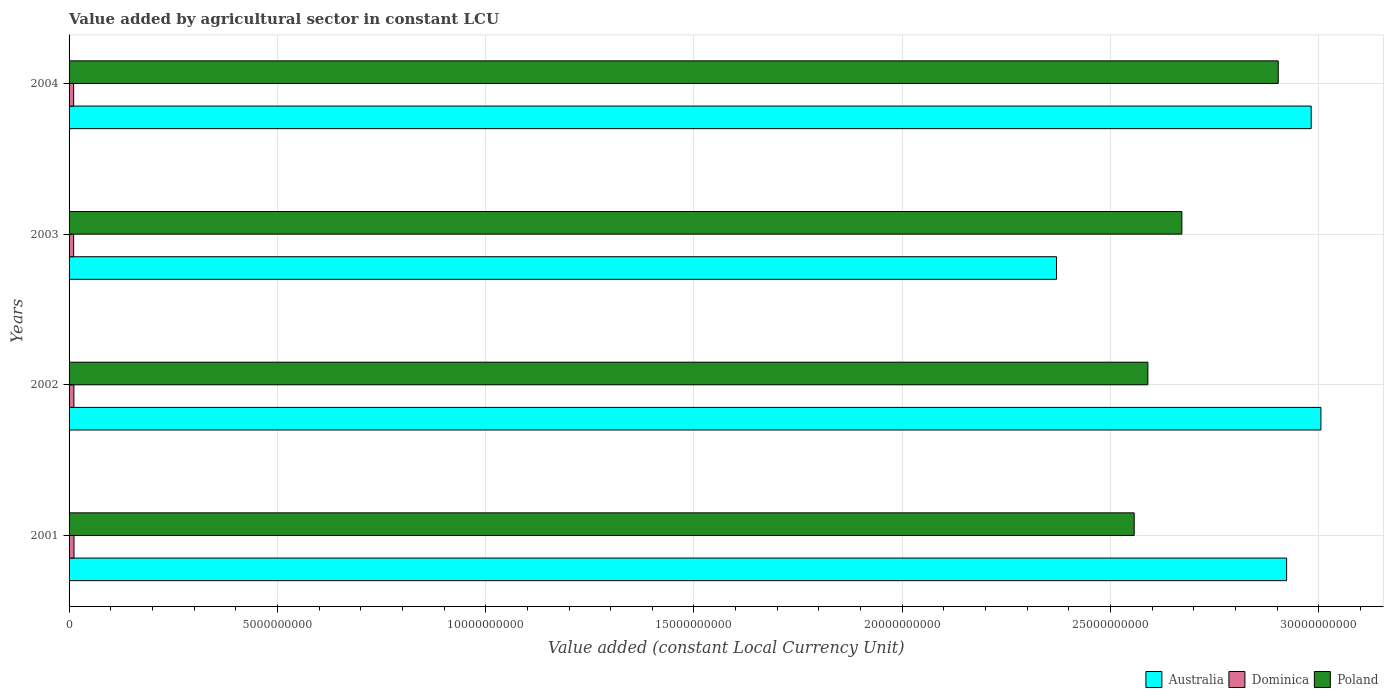How many different coloured bars are there?
Keep it short and to the point. 3. How many groups of bars are there?
Provide a succinct answer. 4. Are the number of bars per tick equal to the number of legend labels?
Provide a succinct answer. Yes. How many bars are there on the 3rd tick from the bottom?
Your response must be concise. 3. What is the label of the 3rd group of bars from the top?
Offer a very short reply. 2002. In how many cases, is the number of bars for a given year not equal to the number of legend labels?
Provide a short and direct response. 0. What is the value added by agricultural sector in Australia in 2003?
Keep it short and to the point. 2.37e+1. Across all years, what is the maximum value added by agricultural sector in Dominica?
Give a very brief answer. 1.18e+08. Across all years, what is the minimum value added by agricultural sector in Dominica?
Offer a very short reply. 1.10e+08. In which year was the value added by agricultural sector in Poland maximum?
Your answer should be compact. 2004. What is the total value added by agricultural sector in Australia in the graph?
Offer a terse response. 1.13e+11. What is the difference between the value added by agricultural sector in Poland in 2002 and that in 2004?
Make the answer very short. -3.13e+09. What is the difference between the value added by agricultural sector in Dominica in 2001 and the value added by agricultural sector in Poland in 2002?
Your response must be concise. -2.58e+1. What is the average value added by agricultural sector in Poland per year?
Keep it short and to the point. 2.68e+1. In the year 2002, what is the difference between the value added by agricultural sector in Poland and value added by agricultural sector in Australia?
Your response must be concise. -4.15e+09. What is the ratio of the value added by agricultural sector in Australia in 2003 to that in 2004?
Ensure brevity in your answer.  0.79. Is the value added by agricultural sector in Dominica in 2001 less than that in 2002?
Provide a succinct answer. No. Is the difference between the value added by agricultural sector in Poland in 2001 and 2004 greater than the difference between the value added by agricultural sector in Australia in 2001 and 2004?
Your answer should be very brief. No. What is the difference between the highest and the second highest value added by agricultural sector in Dominica?
Offer a very short reply. 2.83e+06. What is the difference between the highest and the lowest value added by agricultural sector in Australia?
Offer a terse response. 6.35e+09. Is the sum of the value added by agricultural sector in Dominica in 2002 and 2004 greater than the maximum value added by agricultural sector in Poland across all years?
Keep it short and to the point. No. What does the 2nd bar from the top in 2003 represents?
Provide a succinct answer. Dominica. What does the 3rd bar from the bottom in 2002 represents?
Give a very brief answer. Poland. Is it the case that in every year, the sum of the value added by agricultural sector in Australia and value added by agricultural sector in Dominica is greater than the value added by agricultural sector in Poland?
Make the answer very short. No. Are all the bars in the graph horizontal?
Make the answer very short. Yes. Are the values on the major ticks of X-axis written in scientific E-notation?
Provide a succinct answer. No. Does the graph contain any zero values?
Your answer should be very brief. No. What is the title of the graph?
Provide a succinct answer. Value added by agricultural sector in constant LCU. What is the label or title of the X-axis?
Offer a very short reply. Value added (constant Local Currency Unit). What is the label or title of the Y-axis?
Provide a succinct answer. Years. What is the Value added (constant Local Currency Unit) in Australia in 2001?
Keep it short and to the point. 2.92e+1. What is the Value added (constant Local Currency Unit) of Dominica in 2001?
Your answer should be compact. 1.18e+08. What is the Value added (constant Local Currency Unit) in Poland in 2001?
Provide a short and direct response. 2.56e+1. What is the Value added (constant Local Currency Unit) of Australia in 2002?
Give a very brief answer. 3.00e+1. What is the Value added (constant Local Currency Unit) in Dominica in 2002?
Your answer should be very brief. 1.16e+08. What is the Value added (constant Local Currency Unit) in Poland in 2002?
Provide a short and direct response. 2.59e+1. What is the Value added (constant Local Currency Unit) of Australia in 2003?
Provide a succinct answer. 2.37e+1. What is the Value added (constant Local Currency Unit) of Dominica in 2003?
Your answer should be compact. 1.10e+08. What is the Value added (constant Local Currency Unit) in Poland in 2003?
Offer a terse response. 2.67e+1. What is the Value added (constant Local Currency Unit) of Australia in 2004?
Ensure brevity in your answer.  2.98e+1. What is the Value added (constant Local Currency Unit) in Dominica in 2004?
Ensure brevity in your answer.  1.10e+08. What is the Value added (constant Local Currency Unit) in Poland in 2004?
Provide a succinct answer. 2.90e+1. Across all years, what is the maximum Value added (constant Local Currency Unit) in Australia?
Provide a short and direct response. 3.00e+1. Across all years, what is the maximum Value added (constant Local Currency Unit) of Dominica?
Offer a very short reply. 1.18e+08. Across all years, what is the maximum Value added (constant Local Currency Unit) in Poland?
Provide a succinct answer. 2.90e+1. Across all years, what is the minimum Value added (constant Local Currency Unit) of Australia?
Your response must be concise. 2.37e+1. Across all years, what is the minimum Value added (constant Local Currency Unit) in Dominica?
Ensure brevity in your answer.  1.10e+08. Across all years, what is the minimum Value added (constant Local Currency Unit) in Poland?
Ensure brevity in your answer.  2.56e+1. What is the total Value added (constant Local Currency Unit) in Australia in the graph?
Provide a short and direct response. 1.13e+11. What is the total Value added (constant Local Currency Unit) of Dominica in the graph?
Your answer should be very brief. 4.53e+08. What is the total Value added (constant Local Currency Unit) of Poland in the graph?
Your answer should be compact. 1.07e+11. What is the difference between the Value added (constant Local Currency Unit) in Australia in 2001 and that in 2002?
Provide a succinct answer. -8.23e+08. What is the difference between the Value added (constant Local Currency Unit) in Dominica in 2001 and that in 2002?
Keep it short and to the point. 2.83e+06. What is the difference between the Value added (constant Local Currency Unit) of Poland in 2001 and that in 2002?
Provide a succinct answer. -3.28e+08. What is the difference between the Value added (constant Local Currency Unit) of Australia in 2001 and that in 2003?
Your answer should be very brief. 5.52e+09. What is the difference between the Value added (constant Local Currency Unit) in Dominica in 2001 and that in 2003?
Ensure brevity in your answer.  8.81e+06. What is the difference between the Value added (constant Local Currency Unit) of Poland in 2001 and that in 2003?
Ensure brevity in your answer.  -1.14e+09. What is the difference between the Value added (constant Local Currency Unit) in Australia in 2001 and that in 2004?
Keep it short and to the point. -5.90e+08. What is the difference between the Value added (constant Local Currency Unit) of Dominica in 2001 and that in 2004?
Your response must be concise. 8.70e+06. What is the difference between the Value added (constant Local Currency Unit) of Poland in 2001 and that in 2004?
Provide a succinct answer. -3.46e+09. What is the difference between the Value added (constant Local Currency Unit) of Australia in 2002 and that in 2003?
Ensure brevity in your answer.  6.35e+09. What is the difference between the Value added (constant Local Currency Unit) of Dominica in 2002 and that in 2003?
Offer a terse response. 5.99e+06. What is the difference between the Value added (constant Local Currency Unit) in Poland in 2002 and that in 2003?
Offer a very short reply. -8.16e+08. What is the difference between the Value added (constant Local Currency Unit) of Australia in 2002 and that in 2004?
Your response must be concise. 2.33e+08. What is the difference between the Value added (constant Local Currency Unit) of Dominica in 2002 and that in 2004?
Give a very brief answer. 5.87e+06. What is the difference between the Value added (constant Local Currency Unit) in Poland in 2002 and that in 2004?
Your answer should be very brief. -3.13e+09. What is the difference between the Value added (constant Local Currency Unit) in Australia in 2003 and that in 2004?
Offer a terse response. -6.11e+09. What is the difference between the Value added (constant Local Currency Unit) of Dominica in 2003 and that in 2004?
Keep it short and to the point. -1.18e+05. What is the difference between the Value added (constant Local Currency Unit) of Poland in 2003 and that in 2004?
Ensure brevity in your answer.  -2.31e+09. What is the difference between the Value added (constant Local Currency Unit) of Australia in 2001 and the Value added (constant Local Currency Unit) of Dominica in 2002?
Ensure brevity in your answer.  2.91e+1. What is the difference between the Value added (constant Local Currency Unit) of Australia in 2001 and the Value added (constant Local Currency Unit) of Poland in 2002?
Your response must be concise. 3.33e+09. What is the difference between the Value added (constant Local Currency Unit) of Dominica in 2001 and the Value added (constant Local Currency Unit) of Poland in 2002?
Offer a terse response. -2.58e+1. What is the difference between the Value added (constant Local Currency Unit) in Australia in 2001 and the Value added (constant Local Currency Unit) in Dominica in 2003?
Give a very brief answer. 2.91e+1. What is the difference between the Value added (constant Local Currency Unit) of Australia in 2001 and the Value added (constant Local Currency Unit) of Poland in 2003?
Your answer should be very brief. 2.51e+09. What is the difference between the Value added (constant Local Currency Unit) in Dominica in 2001 and the Value added (constant Local Currency Unit) in Poland in 2003?
Your answer should be very brief. -2.66e+1. What is the difference between the Value added (constant Local Currency Unit) in Australia in 2001 and the Value added (constant Local Currency Unit) in Dominica in 2004?
Offer a terse response. 2.91e+1. What is the difference between the Value added (constant Local Currency Unit) of Australia in 2001 and the Value added (constant Local Currency Unit) of Poland in 2004?
Make the answer very short. 2.01e+08. What is the difference between the Value added (constant Local Currency Unit) in Dominica in 2001 and the Value added (constant Local Currency Unit) in Poland in 2004?
Your answer should be compact. -2.89e+1. What is the difference between the Value added (constant Local Currency Unit) in Australia in 2002 and the Value added (constant Local Currency Unit) in Dominica in 2003?
Give a very brief answer. 2.99e+1. What is the difference between the Value added (constant Local Currency Unit) of Australia in 2002 and the Value added (constant Local Currency Unit) of Poland in 2003?
Give a very brief answer. 3.34e+09. What is the difference between the Value added (constant Local Currency Unit) in Dominica in 2002 and the Value added (constant Local Currency Unit) in Poland in 2003?
Provide a short and direct response. -2.66e+1. What is the difference between the Value added (constant Local Currency Unit) of Australia in 2002 and the Value added (constant Local Currency Unit) of Dominica in 2004?
Ensure brevity in your answer.  2.99e+1. What is the difference between the Value added (constant Local Currency Unit) in Australia in 2002 and the Value added (constant Local Currency Unit) in Poland in 2004?
Make the answer very short. 1.02e+09. What is the difference between the Value added (constant Local Currency Unit) in Dominica in 2002 and the Value added (constant Local Currency Unit) in Poland in 2004?
Ensure brevity in your answer.  -2.89e+1. What is the difference between the Value added (constant Local Currency Unit) in Australia in 2003 and the Value added (constant Local Currency Unit) in Dominica in 2004?
Provide a short and direct response. 2.36e+1. What is the difference between the Value added (constant Local Currency Unit) in Australia in 2003 and the Value added (constant Local Currency Unit) in Poland in 2004?
Give a very brief answer. -5.32e+09. What is the difference between the Value added (constant Local Currency Unit) in Dominica in 2003 and the Value added (constant Local Currency Unit) in Poland in 2004?
Give a very brief answer. -2.89e+1. What is the average Value added (constant Local Currency Unit) of Australia per year?
Your answer should be compact. 2.82e+1. What is the average Value added (constant Local Currency Unit) of Dominica per year?
Make the answer very short. 1.13e+08. What is the average Value added (constant Local Currency Unit) of Poland per year?
Give a very brief answer. 2.68e+1. In the year 2001, what is the difference between the Value added (constant Local Currency Unit) of Australia and Value added (constant Local Currency Unit) of Dominica?
Provide a short and direct response. 2.91e+1. In the year 2001, what is the difference between the Value added (constant Local Currency Unit) in Australia and Value added (constant Local Currency Unit) in Poland?
Offer a very short reply. 3.66e+09. In the year 2001, what is the difference between the Value added (constant Local Currency Unit) of Dominica and Value added (constant Local Currency Unit) of Poland?
Give a very brief answer. -2.54e+1. In the year 2002, what is the difference between the Value added (constant Local Currency Unit) of Australia and Value added (constant Local Currency Unit) of Dominica?
Provide a succinct answer. 2.99e+1. In the year 2002, what is the difference between the Value added (constant Local Currency Unit) in Australia and Value added (constant Local Currency Unit) in Poland?
Offer a terse response. 4.15e+09. In the year 2002, what is the difference between the Value added (constant Local Currency Unit) in Dominica and Value added (constant Local Currency Unit) in Poland?
Offer a very short reply. -2.58e+1. In the year 2003, what is the difference between the Value added (constant Local Currency Unit) of Australia and Value added (constant Local Currency Unit) of Dominica?
Provide a succinct answer. 2.36e+1. In the year 2003, what is the difference between the Value added (constant Local Currency Unit) of Australia and Value added (constant Local Currency Unit) of Poland?
Make the answer very short. -3.01e+09. In the year 2003, what is the difference between the Value added (constant Local Currency Unit) in Dominica and Value added (constant Local Currency Unit) in Poland?
Your answer should be compact. -2.66e+1. In the year 2004, what is the difference between the Value added (constant Local Currency Unit) in Australia and Value added (constant Local Currency Unit) in Dominica?
Make the answer very short. 2.97e+1. In the year 2004, what is the difference between the Value added (constant Local Currency Unit) of Australia and Value added (constant Local Currency Unit) of Poland?
Provide a succinct answer. 7.91e+08. In the year 2004, what is the difference between the Value added (constant Local Currency Unit) in Dominica and Value added (constant Local Currency Unit) in Poland?
Your answer should be compact. -2.89e+1. What is the ratio of the Value added (constant Local Currency Unit) in Australia in 2001 to that in 2002?
Offer a terse response. 0.97. What is the ratio of the Value added (constant Local Currency Unit) in Dominica in 2001 to that in 2002?
Provide a short and direct response. 1.02. What is the ratio of the Value added (constant Local Currency Unit) of Poland in 2001 to that in 2002?
Keep it short and to the point. 0.99. What is the ratio of the Value added (constant Local Currency Unit) of Australia in 2001 to that in 2003?
Give a very brief answer. 1.23. What is the ratio of the Value added (constant Local Currency Unit) in Dominica in 2001 to that in 2003?
Provide a short and direct response. 1.08. What is the ratio of the Value added (constant Local Currency Unit) of Poland in 2001 to that in 2003?
Your answer should be very brief. 0.96. What is the ratio of the Value added (constant Local Currency Unit) of Australia in 2001 to that in 2004?
Your answer should be compact. 0.98. What is the ratio of the Value added (constant Local Currency Unit) in Dominica in 2001 to that in 2004?
Provide a succinct answer. 1.08. What is the ratio of the Value added (constant Local Currency Unit) in Poland in 2001 to that in 2004?
Keep it short and to the point. 0.88. What is the ratio of the Value added (constant Local Currency Unit) of Australia in 2002 to that in 2003?
Offer a terse response. 1.27. What is the ratio of the Value added (constant Local Currency Unit) in Dominica in 2002 to that in 2003?
Provide a succinct answer. 1.05. What is the ratio of the Value added (constant Local Currency Unit) of Poland in 2002 to that in 2003?
Provide a short and direct response. 0.97. What is the ratio of the Value added (constant Local Currency Unit) of Australia in 2002 to that in 2004?
Offer a very short reply. 1.01. What is the ratio of the Value added (constant Local Currency Unit) of Dominica in 2002 to that in 2004?
Offer a terse response. 1.05. What is the ratio of the Value added (constant Local Currency Unit) in Poland in 2002 to that in 2004?
Ensure brevity in your answer.  0.89. What is the ratio of the Value added (constant Local Currency Unit) in Australia in 2003 to that in 2004?
Make the answer very short. 0.79. What is the ratio of the Value added (constant Local Currency Unit) of Poland in 2003 to that in 2004?
Offer a very short reply. 0.92. What is the difference between the highest and the second highest Value added (constant Local Currency Unit) in Australia?
Your answer should be compact. 2.33e+08. What is the difference between the highest and the second highest Value added (constant Local Currency Unit) of Dominica?
Keep it short and to the point. 2.83e+06. What is the difference between the highest and the second highest Value added (constant Local Currency Unit) in Poland?
Ensure brevity in your answer.  2.31e+09. What is the difference between the highest and the lowest Value added (constant Local Currency Unit) in Australia?
Keep it short and to the point. 6.35e+09. What is the difference between the highest and the lowest Value added (constant Local Currency Unit) of Dominica?
Provide a succinct answer. 8.81e+06. What is the difference between the highest and the lowest Value added (constant Local Currency Unit) in Poland?
Provide a succinct answer. 3.46e+09. 